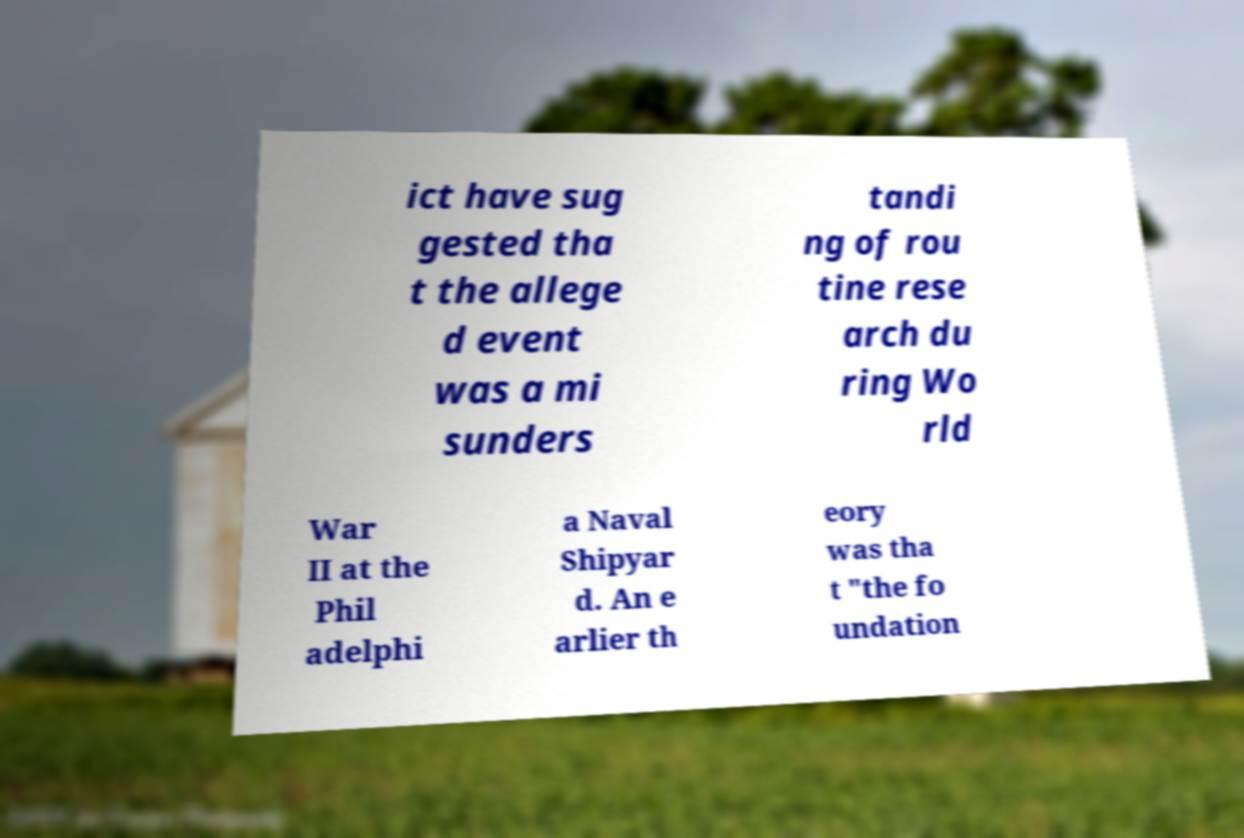Could you assist in decoding the text presented in this image and type it out clearly? ict have sug gested tha t the allege d event was a mi sunders tandi ng of rou tine rese arch du ring Wo rld War II at the Phil adelphi a Naval Shipyar d. An e arlier th eory was tha t "the fo undation 